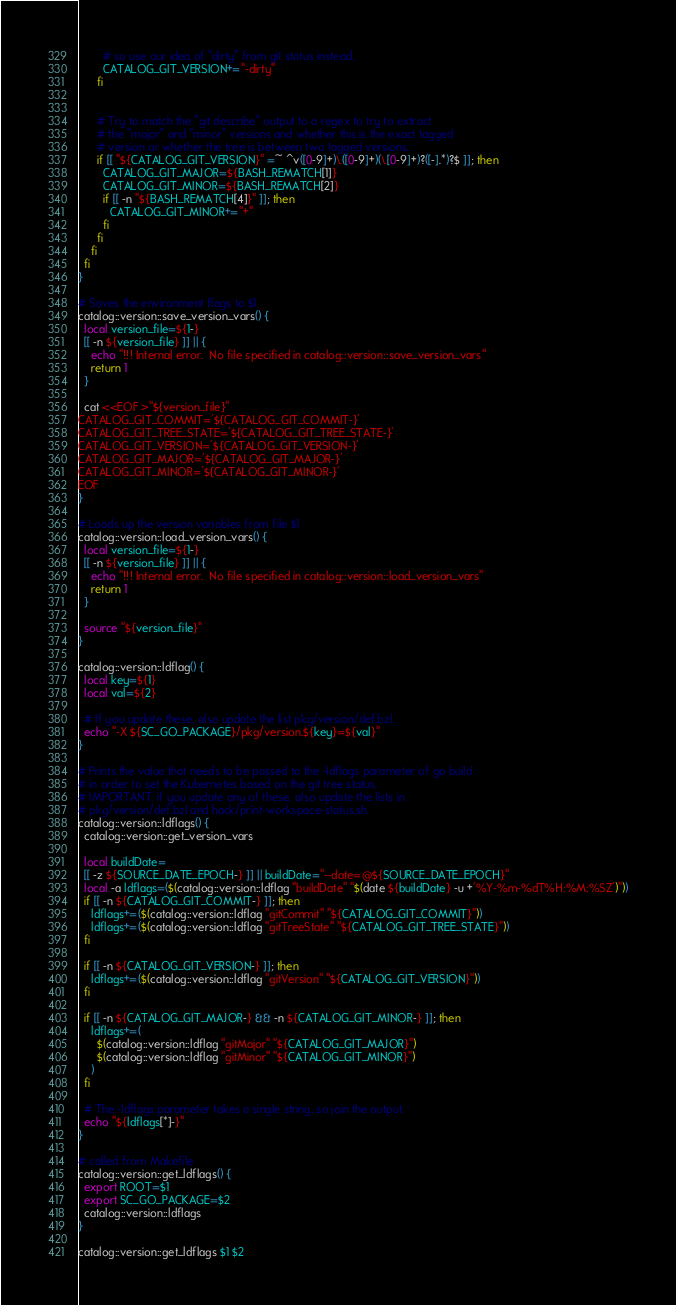Convert code to text. <code><loc_0><loc_0><loc_500><loc_500><_Bash_>        # so use our idea of "dirty" from git status instead.
        CATALOG_GIT_VERSION+="-dirty"
      fi


      # Try to match the "git describe" output to a regex to try to extract
      # the "major" and "minor" versions and whether this is the exact tagged
      # version or whether the tree is between two tagged versions.
      if [[ "${CATALOG_GIT_VERSION}" =~ ^v([0-9]+)\.([0-9]+)(\.[0-9]+)?([-].*)?$ ]]; then
        CATALOG_GIT_MAJOR=${BASH_REMATCH[1]}
        CATALOG_GIT_MINOR=${BASH_REMATCH[2]}
        if [[ -n "${BASH_REMATCH[4]}" ]]; then
          CATALOG_GIT_MINOR+="+"
        fi
      fi
    fi
  fi
}

# Saves the environment flags to $1
catalog::version::save_version_vars() {
  local version_file=${1-}
  [[ -n ${version_file} ]] || {
    echo "!!! Internal error.  No file specified in catalog::version::save_version_vars"
    return 1
  }

  cat <<EOF >"${version_file}"
CATALOG_GIT_COMMIT='${CATALOG_GIT_COMMIT-}'
CATALOG_GIT_TREE_STATE='${CATALOG_GIT_TREE_STATE-}'
CATALOG_GIT_VERSION='${CATALOG_GIT_VERSION-}'
CATALOG_GIT_MAJOR='${CATALOG_GIT_MAJOR-}'
CATALOG_GIT_MINOR='${CATALOG_GIT_MINOR-}'
EOF
}

# Loads up the version variables from file $1
catalog::version::load_version_vars() {
  local version_file=${1-}
  [[ -n ${version_file} ]] || {
    echo "!!! Internal error.  No file specified in catalog::version::load_version_vars"
    return 1
  }

  source "${version_file}"
}

catalog::version::ldflag() {
  local key=${1}
  local val=${2}

  # If you update these, also update the list pkg/version/def.bzl.
  echo "-X ${SC_GO_PACKAGE}/pkg/version.${key}=${val}"
}

# Prints the value that needs to be passed to the -ldflags parameter of go build
# in order to set the Kubernetes based on the git tree status.
# IMPORTANT: if you update any of these, also update the lists in
# pkg/version/def.bzl and hack/print-workspace-status.sh.
catalog::version::ldflags() {
  catalog::version::get_version_vars

  local buildDate=
  [[ -z ${SOURCE_DATE_EPOCH-} ]] || buildDate="--date=@${SOURCE_DATE_EPOCH}"
  local -a ldflags=($(catalog::version::ldflag "buildDate" "$(date ${buildDate} -u +'%Y-%m-%dT%H:%M:%SZ')"))
  if [[ -n ${CATALOG_GIT_COMMIT-} ]]; then
    ldflags+=($(catalog::version::ldflag "gitCommit" "${CATALOG_GIT_COMMIT}"))
    ldflags+=($(catalog::version::ldflag "gitTreeState" "${CATALOG_GIT_TREE_STATE}"))
  fi

  if [[ -n ${CATALOG_GIT_VERSION-} ]]; then
    ldflags+=($(catalog::version::ldflag "gitVersion" "${CATALOG_GIT_VERSION}"))
  fi

  if [[ -n ${CATALOG_GIT_MAJOR-} && -n ${CATALOG_GIT_MINOR-} ]]; then
    ldflags+=(
      $(catalog::version::ldflag "gitMajor" "${CATALOG_GIT_MAJOR}")
      $(catalog::version::ldflag "gitMinor" "${CATALOG_GIT_MINOR}")
    )
  fi

  # The -ldflags parameter takes a single string, so join the output.
  echo "${ldflags[*]-}"
}

# called from Makefile
catalog::version::get_ldflags() {
  export ROOT=$1
  export SC_GO_PACKAGE=$2
  catalog::version::ldflags
}

catalog::version::get_ldflags $1 $2
</code> 